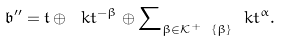<formula> <loc_0><loc_0><loc_500><loc_500>\mathfrak { b } ^ { \prime \prime } = \mathfrak { t } \oplus \ k t ^ { - \beta } \oplus { \sum } _ { \beta \in \mathcal { K } ^ { + } \ \{ \beta \} } \ k t ^ { \alpha } .</formula> 